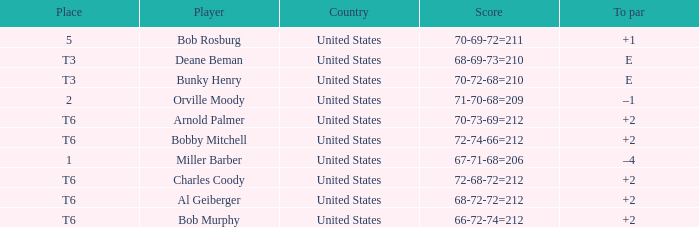Who is the athlete with a t6 position and a 72-68-72=212 score? Charles Coody. 